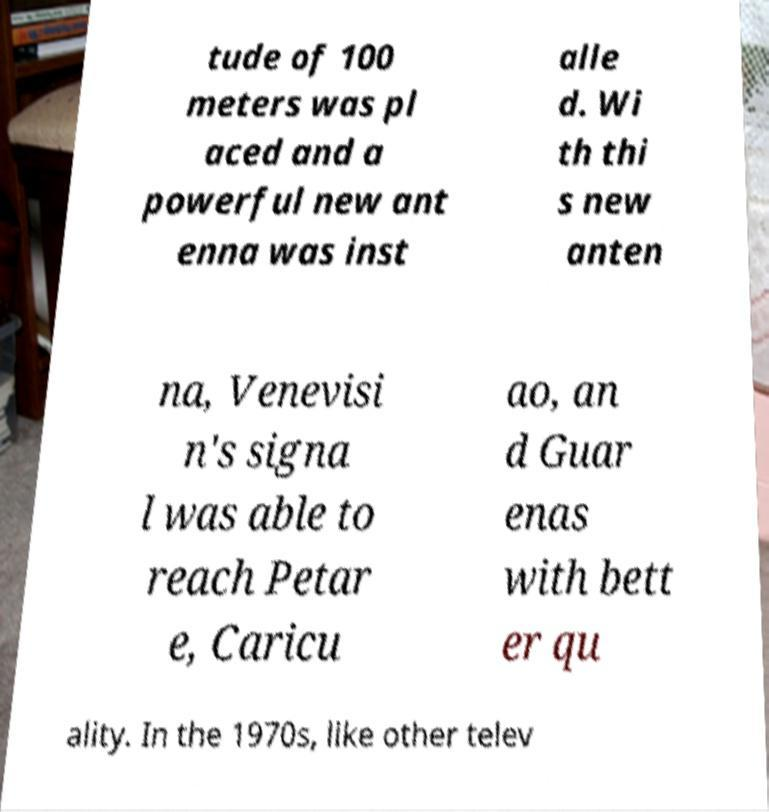What messages or text are displayed in this image? I need them in a readable, typed format. tude of 100 meters was pl aced and a powerful new ant enna was inst alle d. Wi th thi s new anten na, Venevisi n's signa l was able to reach Petar e, Caricu ao, an d Guar enas with bett er qu ality. In the 1970s, like other telev 